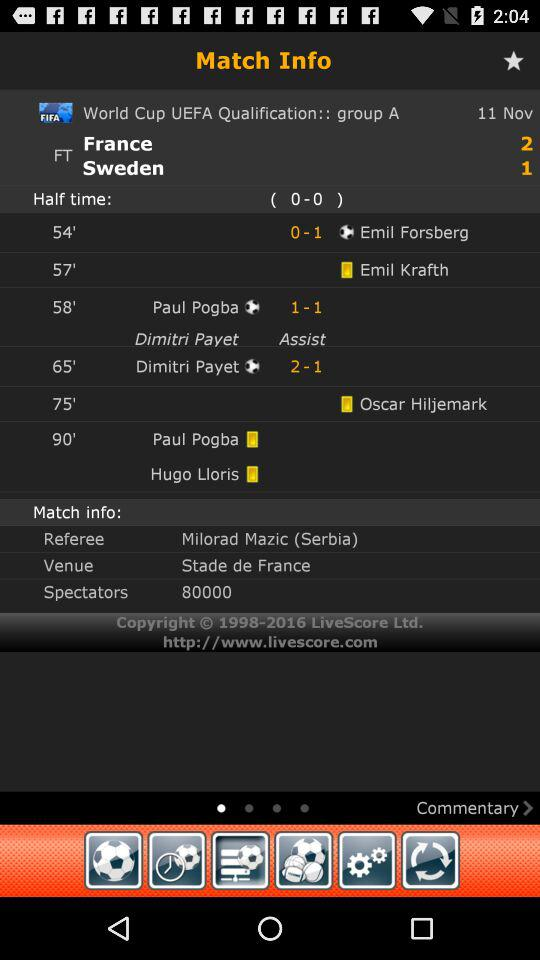For what date are the match scores shown? The date for the match scores shown is November 11. 